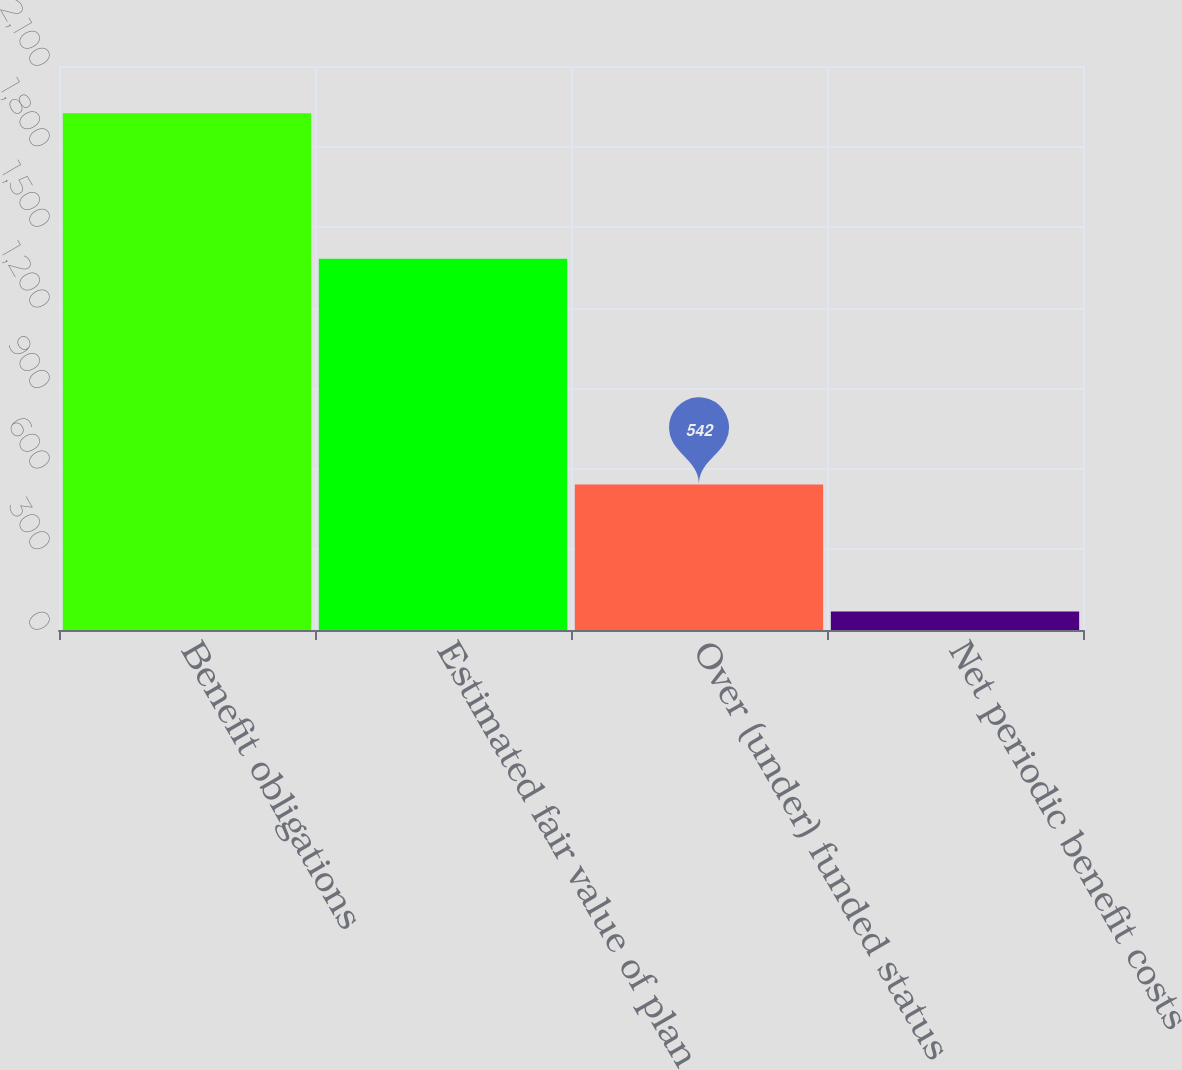<chart> <loc_0><loc_0><loc_500><loc_500><bar_chart><fcel>Benefit obligations<fcel>Estimated fair value of plan<fcel>Over (under) funded status<fcel>Net periodic benefit costs<nl><fcel>1924<fcel>1382<fcel>542<fcel>69<nl></chart> 